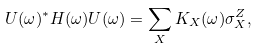Convert formula to latex. <formula><loc_0><loc_0><loc_500><loc_500>U ( \omega ) ^ { * } H ( \omega ) U ( \omega ) = \sum _ { X } K _ { X } ( \omega ) \sigma _ { X } ^ { Z } ,</formula> 